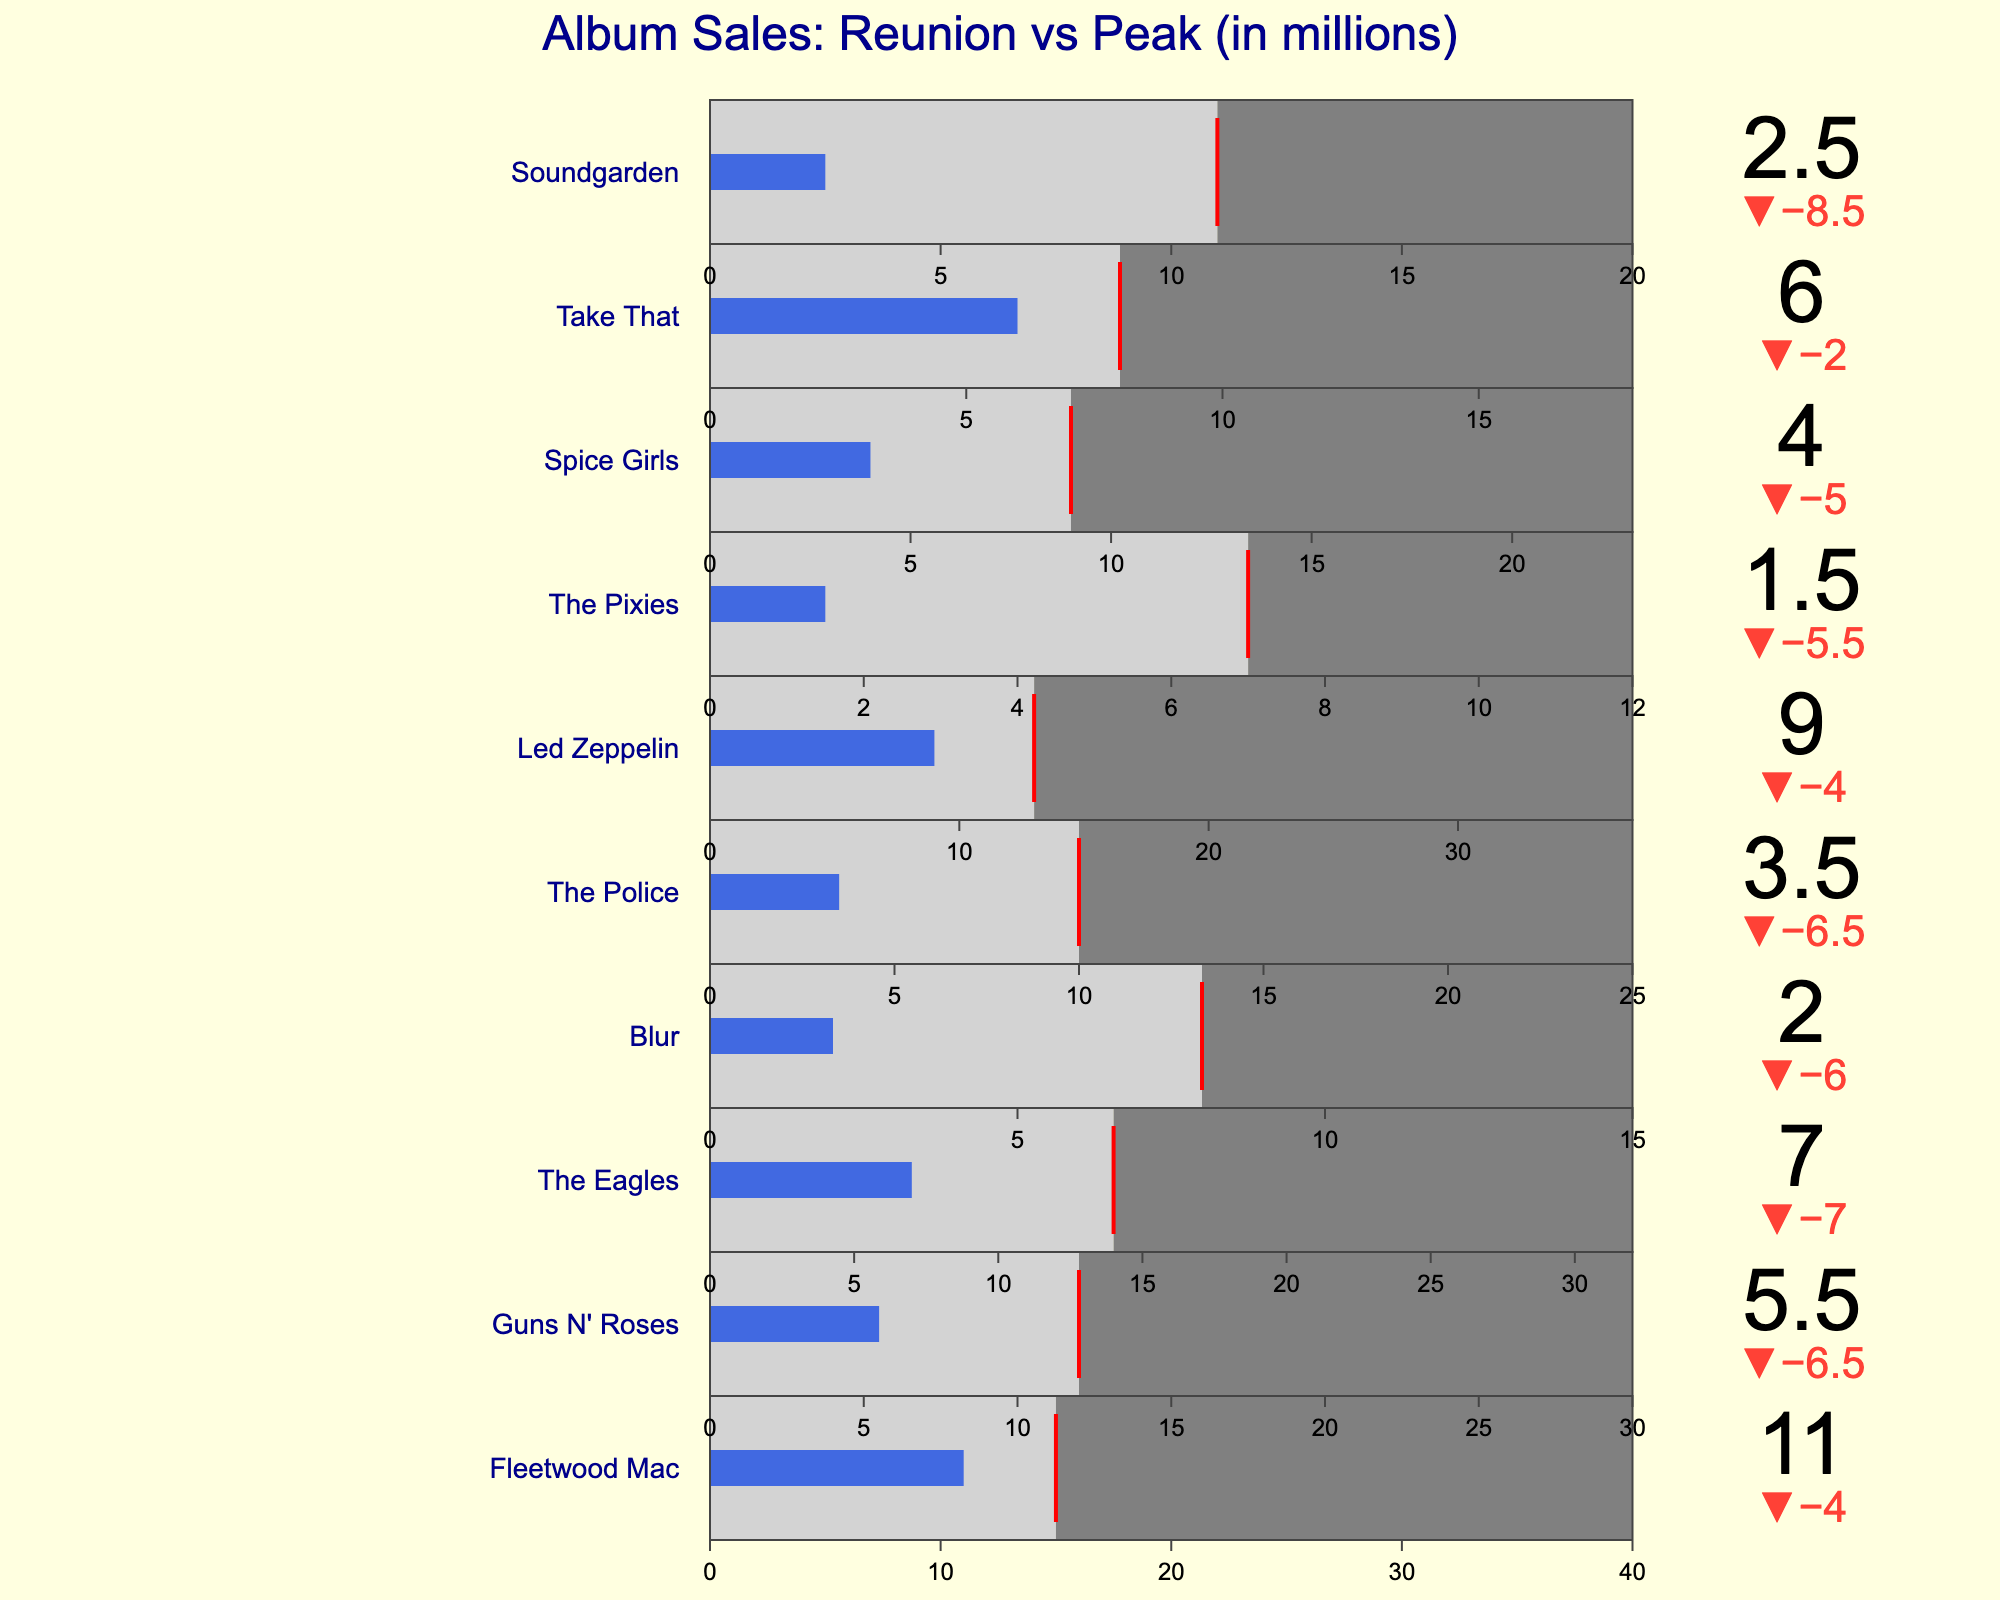How many bands have reunion album sales greater than the industry average? By visually examining the bullet charts, count how many bands have the royal blue bar (reunion album sales) extending beyond the red threshold line (industry average). The bands are: Fleetwood Mac, Led Zeppelin, and Take That.
Answer: 3 What's the title of the figure? The title of the figure is found at the top center of the plot, emphasizing its main subject.
Answer: Album Sales: Reunion vs Peak (in millions) Which band has the largest difference between peak album sales and reunion album sales? To find the largest difference, calculate the difference for each band (Peak Album Sales - Reunion Album Sales) and identify the maximum value. Fleetwood Mac: 40-11=29, Guns N' Roses: 30-5.5=24.5, The Eagles: 32-7=25, Blur: 15-2=13, The Police: 25-3.5=21.5, Led Zeppelin: 37-9=28, The Pixies: 12-1.5=10.5, Spice Girls: 23-4=19, Take That: 18-6=12, Soundgarden: 20-2.5=17. Fleetwood Mac has the largest difference.
Answer: Fleetwood Mac What is the reunion album sales of The Police? Look at the section of the bullet chart corresponding to The Police and read the value indicated by the royal blue bar.
Answer: 3.5 Which band's reunion album sales are just above the industry average? Identify the bands where the royal blue bar (reunion album sales) is just one step above the red line (industry average). The band in this category is Take That.
Answer: Take That Compare the reunion album sales of Led Zeppelin and The Eagles. Which band sold more? Compare the values of the reunion album sales indicated by the royal blue bars for Led Zeppelin and The Eagles. Led Zeppelin's value is 9 while The Eagles' value is 7.
Answer: Led Zeppelin What is the industry average for Guns N' Roses, and how does it compare to their reunion album sales? Find the industry average value marked by the red line for Guns N' Roses and compare it with their reunion album sales shown by the royal blue bar. The industry average is 12, and reunion album sales are 5.5.
Answer: Industry average is 12, reunion album sales are lower at 5.5 How do the reunion album sales of Fleetwood Mac compare to their peak album sales? For Fleetwood Mac, compare the value marked by the royal blue bar (reunion album sales) to the length of the axis which represents peak album sales. The reunion sales are 11, and the peak sales are 40.
Answer: Reunion sales (11) are significantly lower than peak sales (40) Which band has the smallest reunion album sales? Identify the smallest value represented by the royal blue bars across all bands. The smallest value is for The Pixies.
Answer: The Pixies Is the reunion album sales of Blur above or below the industry average? Find the Blur band section, check the value of reunion album sales (royal blue bar), and compare it to the position of the red threshold line (industry average). Reunion album sales (2) are below the industry average (8).
Answer: Below 